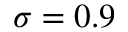Convert formula to latex. <formula><loc_0><loc_0><loc_500><loc_500>\sigma = 0 . 9</formula> 